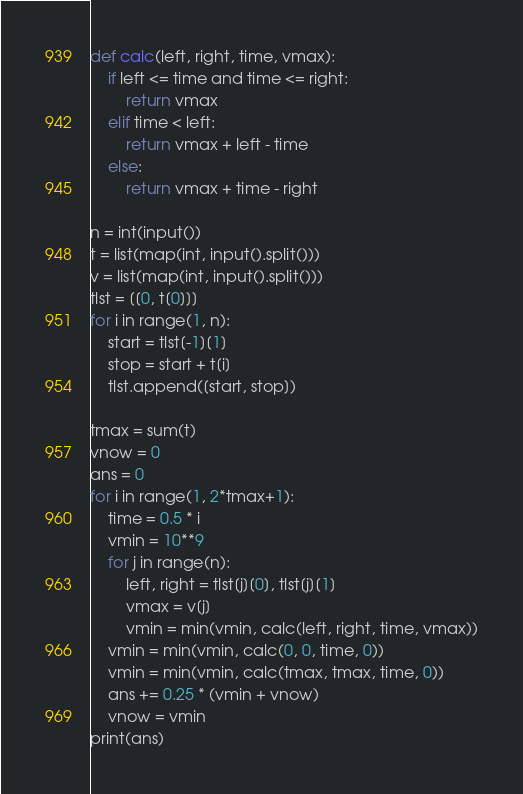Convert code to text. <code><loc_0><loc_0><loc_500><loc_500><_Python_>def calc(left, right, time, vmax):
    if left <= time and time <= right:
        return vmax
    elif time < left:
        return vmax + left - time
    else:
        return vmax + time - right

n = int(input())
t = list(map(int, input().split()))
v = list(map(int, input().split()))
tlst = [[0, t[0]]]
for i in range(1, n):
    start = tlst[-1][1]
    stop = start + t[i]
    tlst.append([start, stop])

tmax = sum(t)
vnow = 0
ans = 0
for i in range(1, 2*tmax+1):
    time = 0.5 * i
    vmin = 10**9
    for j in range(n):
        left, right = tlst[j][0], tlst[j][1]
        vmax = v[j]
        vmin = min(vmin, calc(left, right, time, vmax))
    vmin = min(vmin, calc(0, 0, time, 0))
    vmin = min(vmin, calc(tmax, tmax, time, 0))
    ans += 0.25 * (vmin + vnow)
    vnow = vmin
print(ans)</code> 